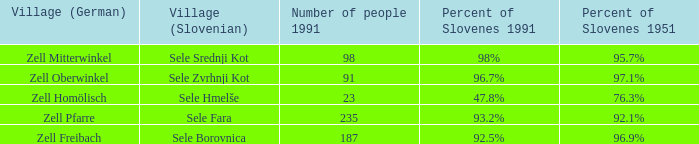Give me the minimum number of people in 1991 with 92.5% of Slovenes in 1991. 187.0. 